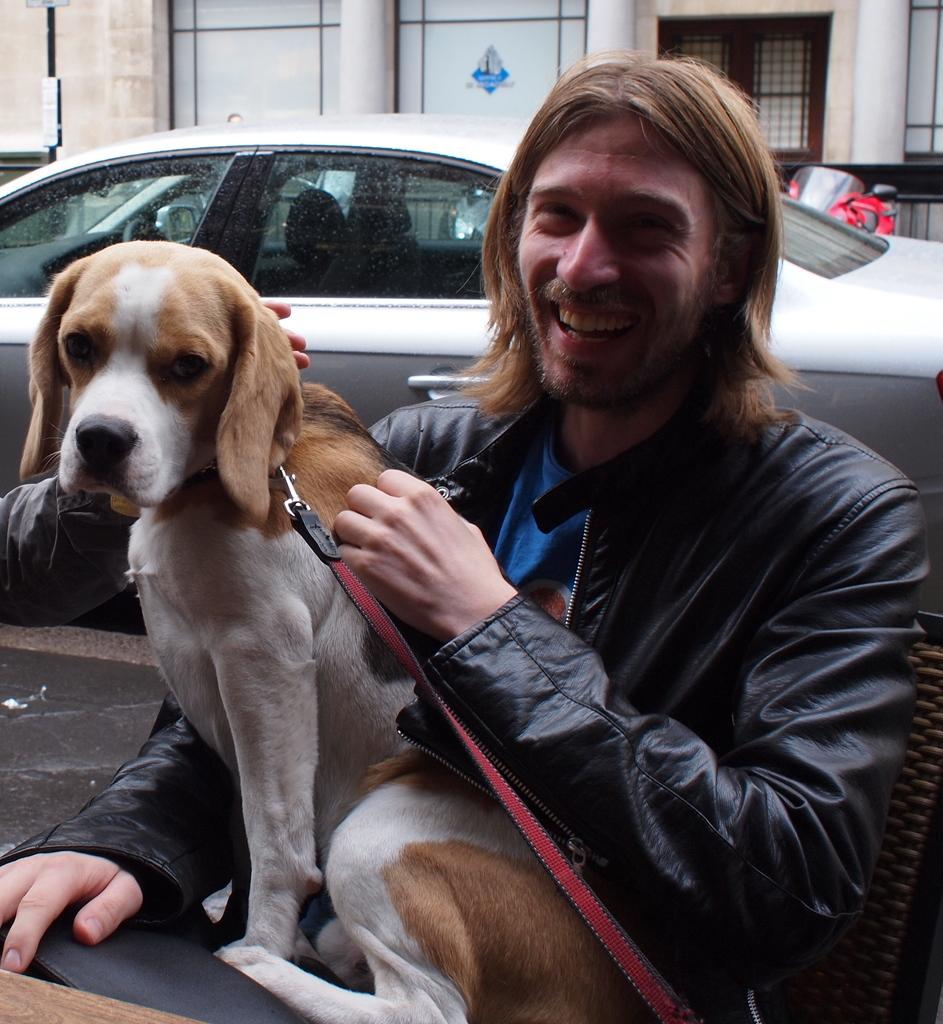Who is present in the image? There is a man in the image. What is the man doing in the image? The man is smiling in the image. What is the man touching in the image? The man has his hand on a dog in the image. What can be seen in the background of the image? There is a car in the background of the image. How many beads are on the dog's collar in the image? There is no mention of beads or a collar on the dog in the image. 